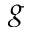<formula> <loc_0><loc_0><loc_500><loc_500>g</formula> 